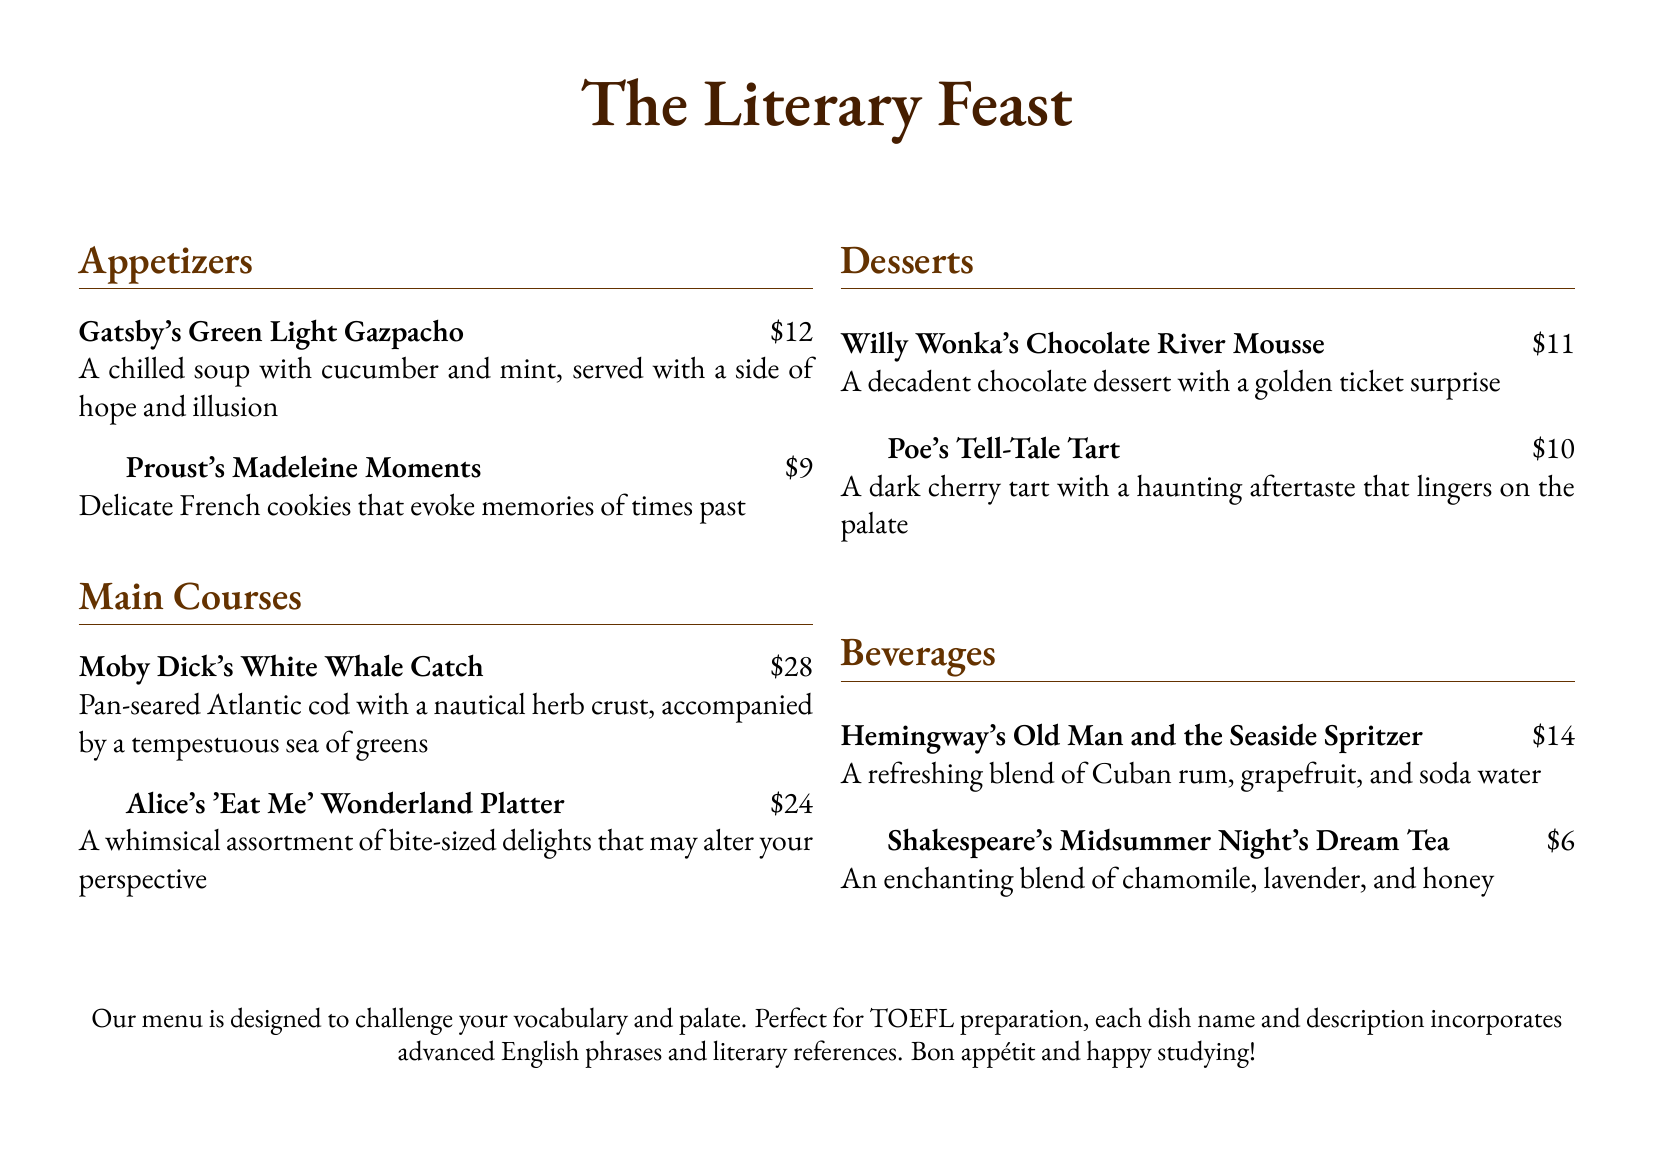What is the name of the dessert inspired by Edgar Allan Poe? The dessert inspired by Edgar Allan Poe is mentioned in the dessert section of the menu.
Answer: Poe's Tell-Tale Tart How much does Hemingway's drink cost? The price of Hemingway's Old Man and the Seaside Spritzer is listed in the beverages section.
Answer: $14 What type of cuisine is represented in Gatsby's Green Light Gazpacho? The dish is a cold soup that reflects a refreshing, light dish typically associated with summer cuisine.
Answer: Soup Which dish contains ingredients that might "alter your perspective"? The dish in question is explicitly described in the main courses section.
Answer: Alice's 'Eat Me' Wonderland Platter What kind of tea is served that references Shakespeare? The beverage inspired by Shakespeare is named in the drinks section of the menu.
Answer: Shakespeare's Midsummer Night's Dream Tea How much is the cost of the Proust's Madeleine Moments? The cost is specifically stated in the appetizers section of the menu.
Answer: $9 What is the main theme of the menu? The overall theme of the menu is derived from certain characteristics of literary works referenced throughout the document.
Answer: Literary works How many appetizers are listed on the menu? The number of appetizers can be counted from the appetizers section in the document.
Answer: Two 